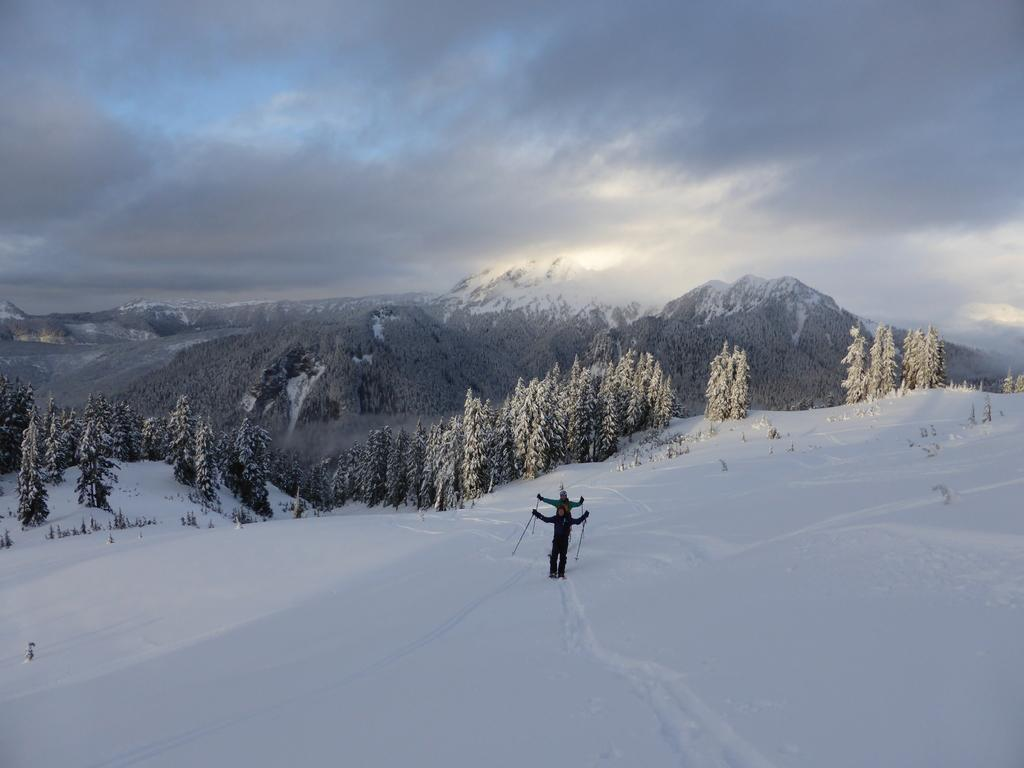How many people are in the image? There are two people in the image. What are the people holding in the image? The people are holding sticks in the image. What is the weather like in the image? There is snow visible in the image, indicating a cold and likely snowy environment. What can be seen in the background of the image? There are trees, hills, and the sky visible in the background of the image. What is the condition of the sky in the image? Clouds are present in the sky in the image. What type of tramp can be seen performing in the image? There is no tramp performing in the image; it features two people holding sticks in a snowy environment. What type of observation can be made about the competition in the image? There is no competition present in the image; it simply shows two people holding sticks in a snowy environment. 